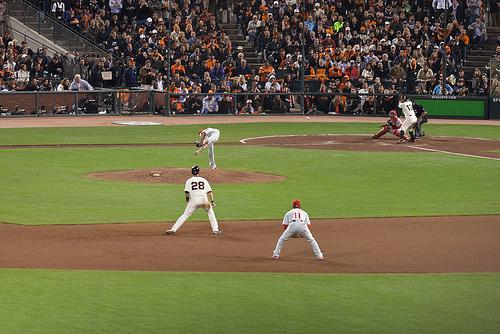Question: where are the fans?
Choices:
A. Behind a wall.
B. Behind a building.
C. Behind a fence.
D. Behind a road.
Answer with the letter. Answer: C Question: what does the pitcher stand on?
Choices:
A. A box.
B. A stool.
C. A bench.
D. A mound.
Answer with the letter. Answer: D Question: where are the helmets?
Choices:
A. On players' heads.
B. In a locker.
C. On the ground.
D. In a bag.
Answer with the letter. Answer: A 